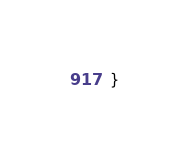<code> <loc_0><loc_0><loc_500><loc_500><_Kotlin_>}
</code> 